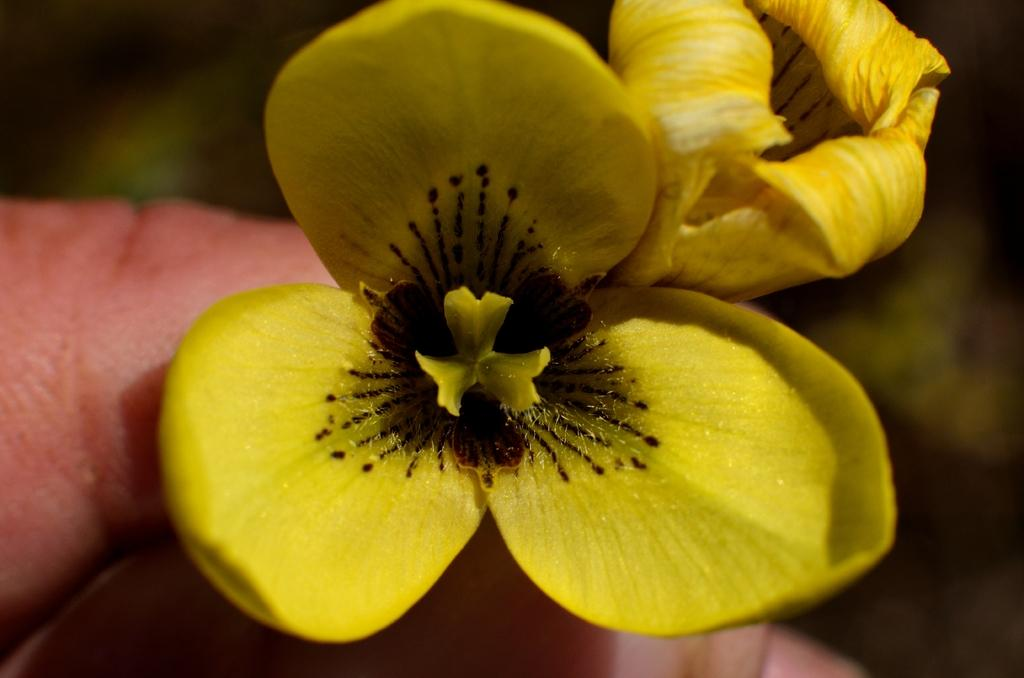What is the main subject of the image? The main subject of the image is a human hand. What is the hand holding in the image? The hand is holding flowers in the image. Can you describe the color of the flowers? The flowers are yellow. What arithmetic problem is the hand solving in the image? There is no arithmetic problem present in the image; it features a hand holding yellow flowers. 